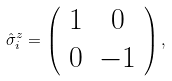<formula> <loc_0><loc_0><loc_500><loc_500>\hat { \sigma } ^ { z } _ { i } = \left ( \begin{array} { c c } 1 & 0 \\ 0 & - 1 \\ \end{array} \right ) ,</formula> 